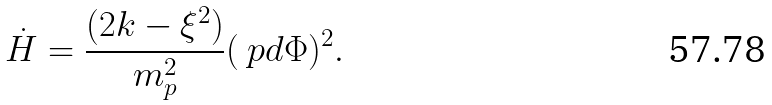Convert formula to latex. <formula><loc_0><loc_0><loc_500><loc_500>\dot { H } = \frac { ( 2 k - \xi ^ { 2 } ) } { m _ { p } ^ { 2 } } ( \ p d \Phi ) ^ { 2 } .</formula> 